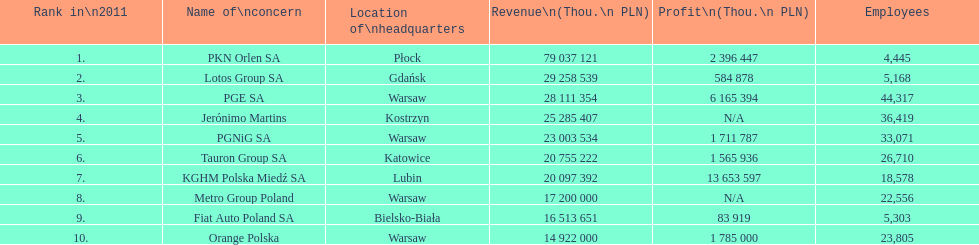What is the number of employees who work for pgnig sa? 33,071. 